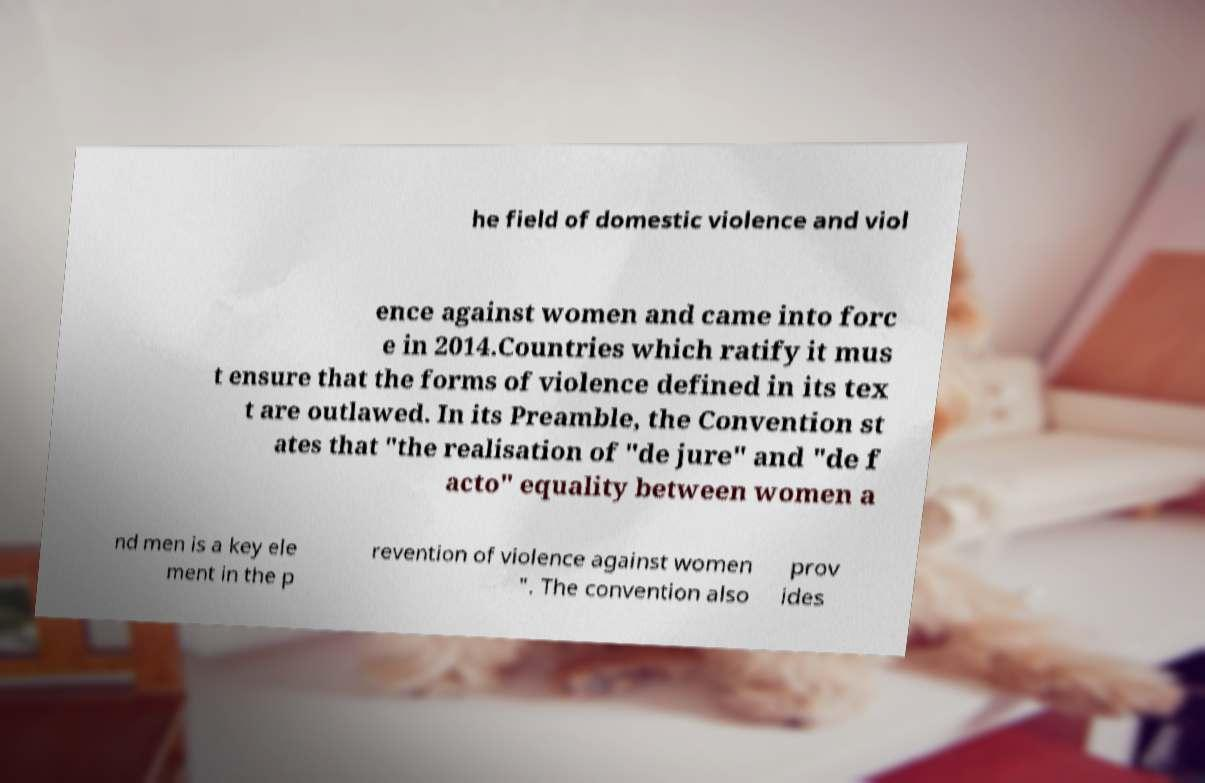Can you read and provide the text displayed in the image?This photo seems to have some interesting text. Can you extract and type it out for me? he field of domestic violence and viol ence against women and came into forc e in 2014.Countries which ratify it mus t ensure that the forms of violence defined in its tex t are outlawed. In its Preamble, the Convention st ates that "the realisation of "de jure" and "de f acto" equality between women a nd men is a key ele ment in the p revention of violence against women ". The convention also prov ides 